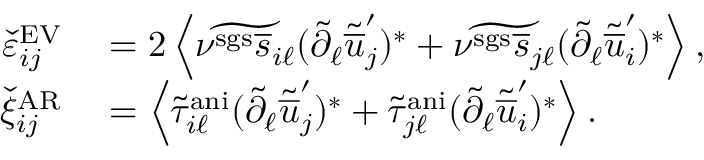<formula> <loc_0><loc_0><loc_500><loc_500>\begin{array} { r l } { \check { \varepsilon } _ { i j } ^ { E V } } & = 2 \left < \widetilde { \nu ^ { s g s } \overline { s } _ { i \ell } } ( \tilde { \partial } _ { \ell } \tilde { \overline { u } } _ { j } ^ { \prime } ) ^ { * } + \widetilde { \nu ^ { s g s } \overline { s } _ { j \ell } } ( \tilde { \partial } _ { \ell } \tilde { \overline { u } } _ { i } ^ { \prime } ) ^ { * } \right > , } \\ { \check { \xi } _ { i j } ^ { A R } } & = \left < \tilde { \tau } _ { i \ell } ^ { a n i } ( \tilde { \partial } _ { \ell } \tilde { \overline { u } } _ { j } ^ { \prime } ) ^ { * } + \tilde { \tau } _ { j \ell } ^ { a n i } ( \tilde { \partial } _ { \ell } \tilde { \overline { u } } _ { i } ^ { \prime } ) ^ { * } \right > . } \end{array}</formula> 